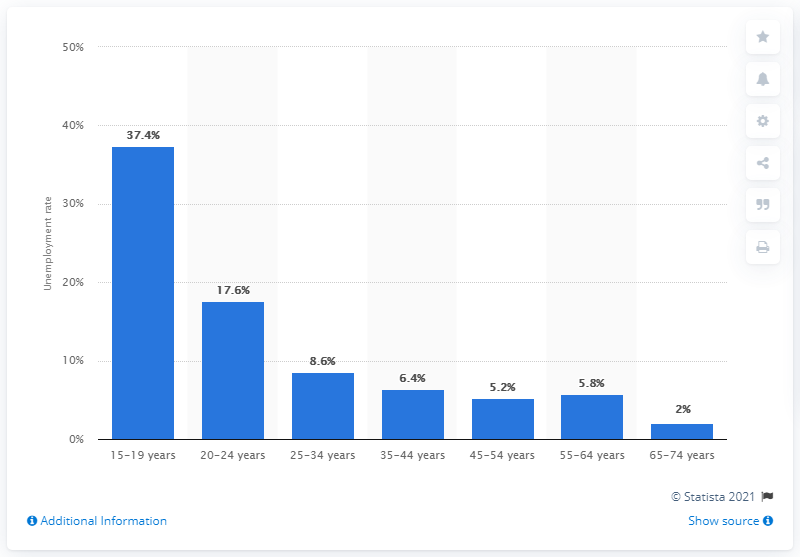Draw attention to some important aspects in this diagram. The highest unemployment rate in history was 35.4%, and the lowest unemployment rate was 2.3%. The unemployment rate among individuals in the age group of 15-19 years is 37.4%. The unemployment rate among 45 to 54 year olds was 5.2%. 